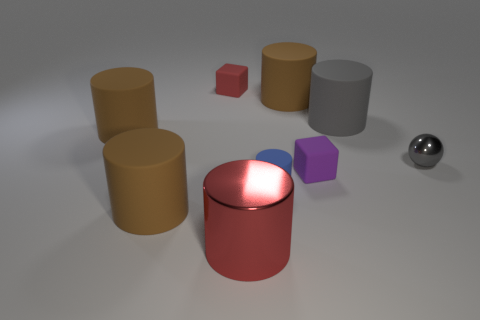Do the red shiny cylinder and the purple rubber thing have the same size?
Offer a terse response. No. How many large things are behind the gray metal object and in front of the small gray metal object?
Your answer should be compact. 0. What number of blue things are tiny metal spheres or big cylinders?
Offer a terse response. 0. What number of matte objects are either small purple cylinders or purple blocks?
Provide a short and direct response. 1. Is there a tiny thing?
Give a very brief answer. Yes. Is the tiny red thing the same shape as the tiny purple matte object?
Offer a terse response. Yes. There is a large cylinder that is in front of the brown object in front of the gray sphere; what number of large brown matte things are in front of it?
Give a very brief answer. 0. What is the thing that is right of the blue matte cylinder and in front of the small gray metal sphere made of?
Your answer should be compact. Rubber. What is the color of the cylinder that is on the right side of the small blue rubber cylinder and on the left side of the gray matte cylinder?
Make the answer very short. Brown. Is there anything else of the same color as the ball?
Your response must be concise. Yes. 